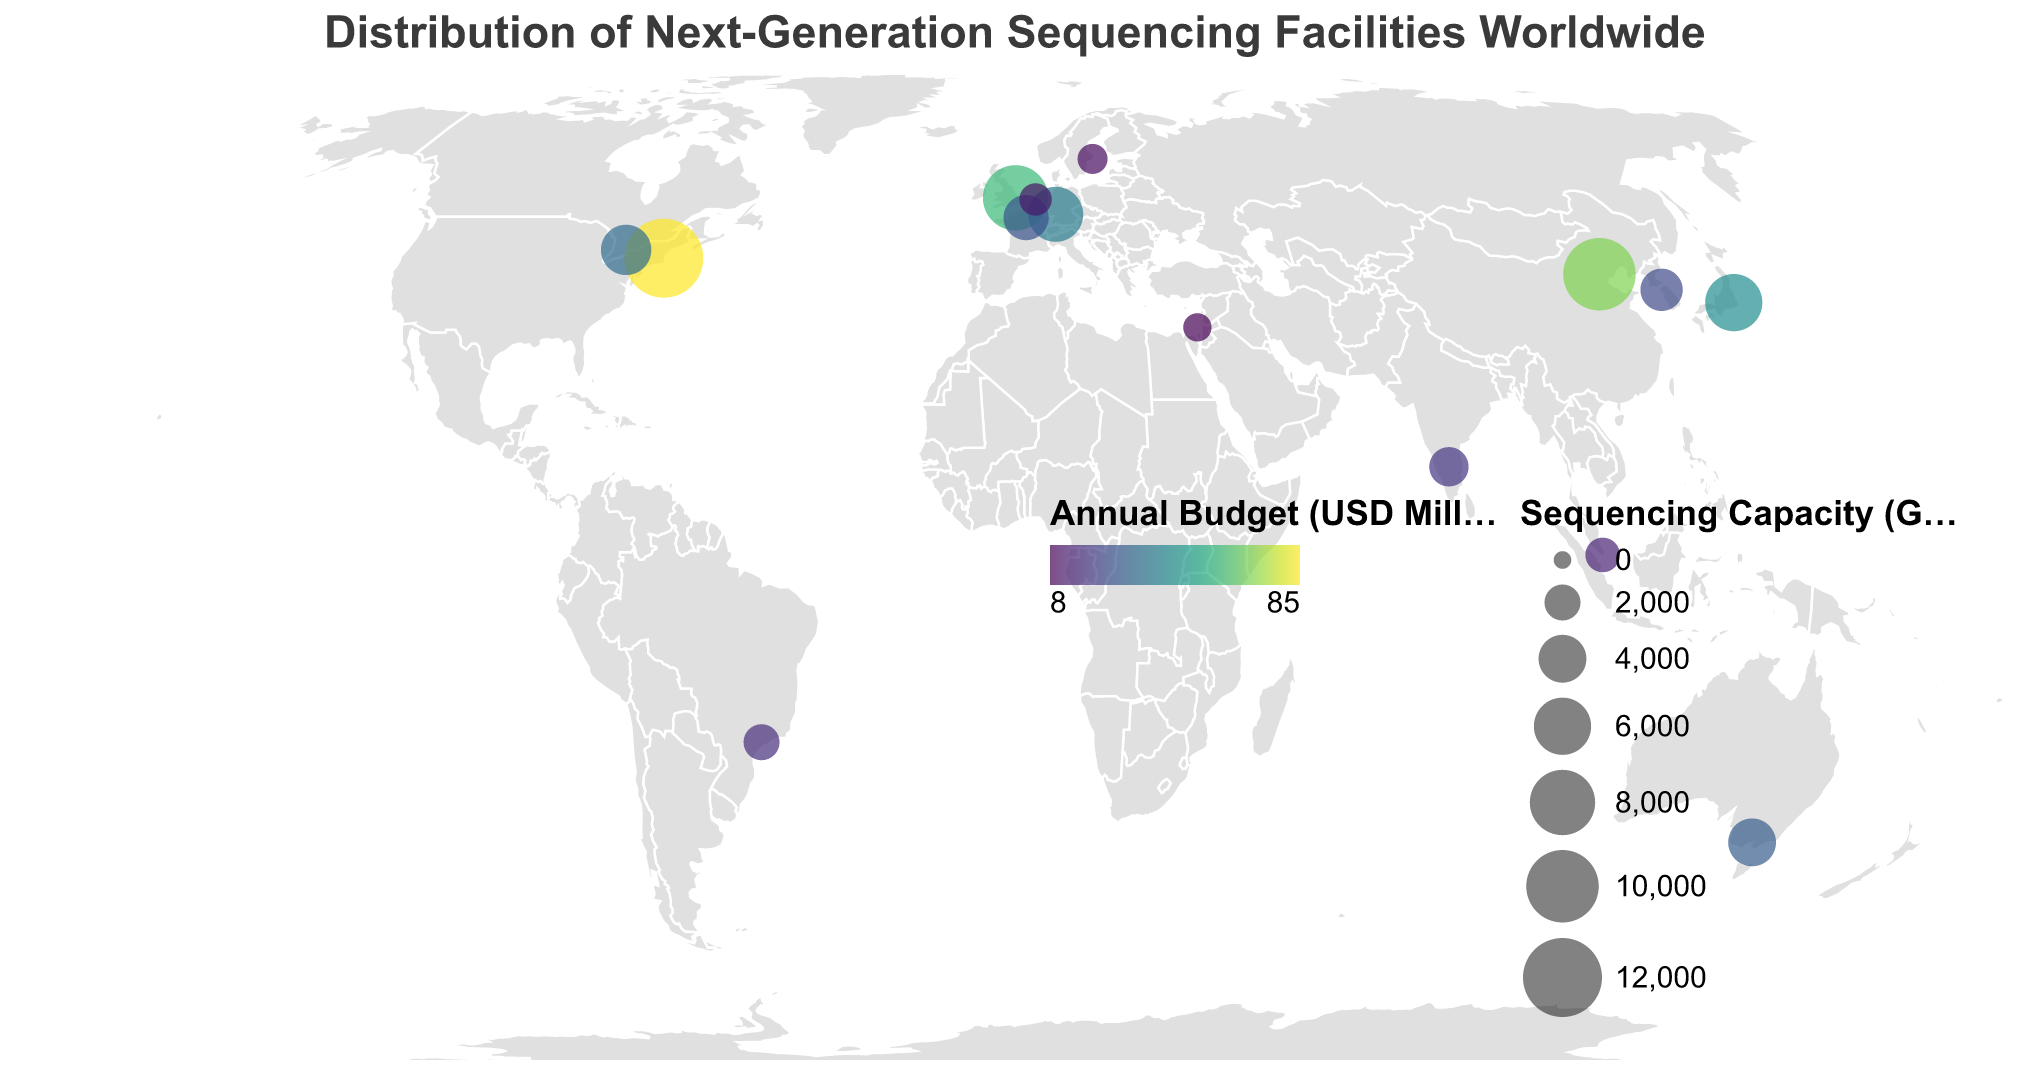What does the color of the circles represent in the figure? The color of the circles represents the annual budget in USD million. This is shown through a color gradient where the legend indicates how lighter or darker shades correspond to different budget amounts.
Answer: The annual budget in USD million How many facilities have a sequencing capacity of 8000 Gb per day or more? From the visual representation, there are three facilities with a sequencing capacity of 8000 Gb per day or more: the Broad Institute in Boston (12,000 Gb), BGI Genomics in Beijing (10,000 Gb), and the Wellcome Sanger Institute in Cambridge (8,000 Gb).
Answer: Three facilities Which facility has the largest sequencing capacity, and where is it located? By looking at the size of the circles, the Broad Institute in Boston, USA, has the largest sequencing capacity of 12,000 Gb per day.
Answer: Broad Institute in Boston, USA What is the difference in sequencing capacity between the facility in Toronto and the one in Paris? The sequencing capacity of the facility in Toronto (The Centre for Applied Genomics) is 4500 Gb per day, and in Paris (Genoscope), it is 3500 Gb per day. Subtracting the two gives 4500 - 3500 = 1000 Gb per day.
Answer: 1,000 Gb per day Which continent has the most sequencing facilities according to the figure? By counting the facilities per continent in the visual, Europe has the most facilities with five locations: Cambridge (UK), Heidelberg (Germany), Paris (France), Rotterdam (Netherlands), and Stockholm (Sweden).
Answer: Europe How does the annual budget of the facility in Tokyo compare to the one in Beijing? The facility in Tokyo (RIKEN Center for Integrative Medical Sciences) has an annual budget of 45 million USD, while the facility in Beijing (BGI Genomics) has an annual budget of 70 million USD. Tokyo's budget is less than Beijing's budget.
Answer: Tokyo's budget is less What is the average annual budget of the facilities in North America? The facilities in North America are in Boston (85 million USD) and Toronto (35 million USD). The average budget is calculated as (85 + 35) / 2 = 60 million USD.
Answer: 60 million USD Which facility in the Southern Hemisphere has the highest sequencing capacity? The figure shows two facilities in the Southern Hemisphere: Australian Genome Research Facility in Melbourne and Brazilian Bioethanol Science and Technology Laboratory in Sao Paulo. The facility in Melbourne has a higher capacity (4,000 Gb per day) than the one in Sao Paulo (2,000 Gb per day).
Answer: Australian Genome Research Facility in Melbourne What is the total sequencing capacity for all facilities in Asia? The facilities in Asia are located in Beijing (10,000 Gb/day), Tokyo (6,000 Gb/day), Seoul (3,000 Gb/day), Bangalore (2,500 Gb/day), and Singapore (1,800 Gb/day). The total is 10,000 + 6,000 + 3,000 + 2,500 + 1,800 = 23,300 Gb/day.
Answer: 23,300 Gb per day 